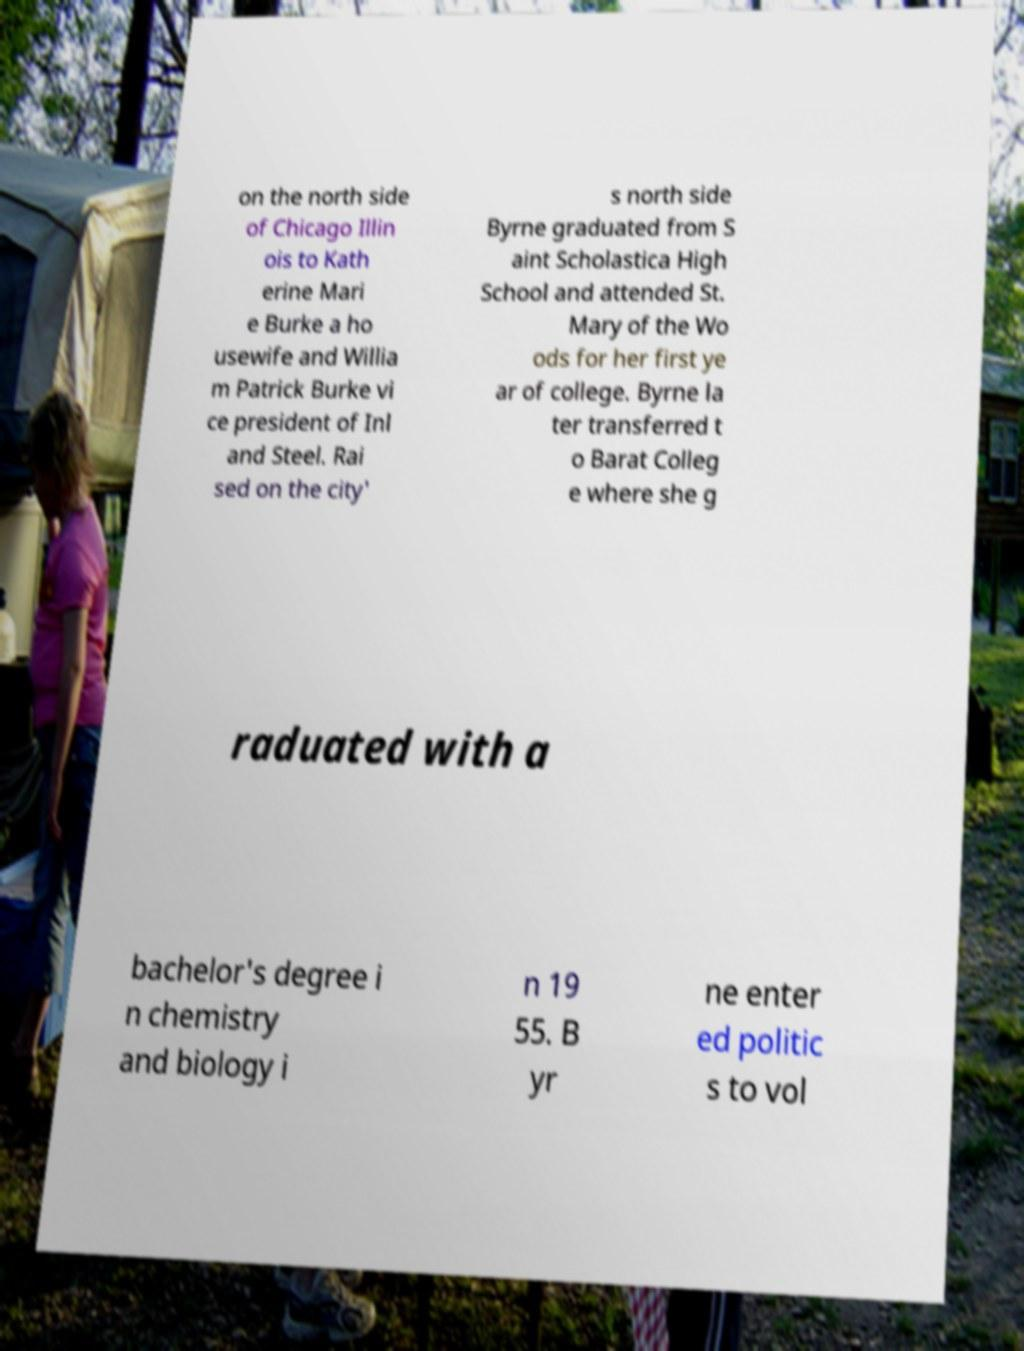Could you extract and type out the text from this image? on the north side of Chicago Illin ois to Kath erine Mari e Burke a ho usewife and Willia m Patrick Burke vi ce president of Inl and Steel. Rai sed on the city' s north side Byrne graduated from S aint Scholastica High School and attended St. Mary of the Wo ods for her first ye ar of college. Byrne la ter transferred t o Barat Colleg e where she g raduated with a bachelor's degree i n chemistry and biology i n 19 55. B yr ne enter ed politic s to vol 